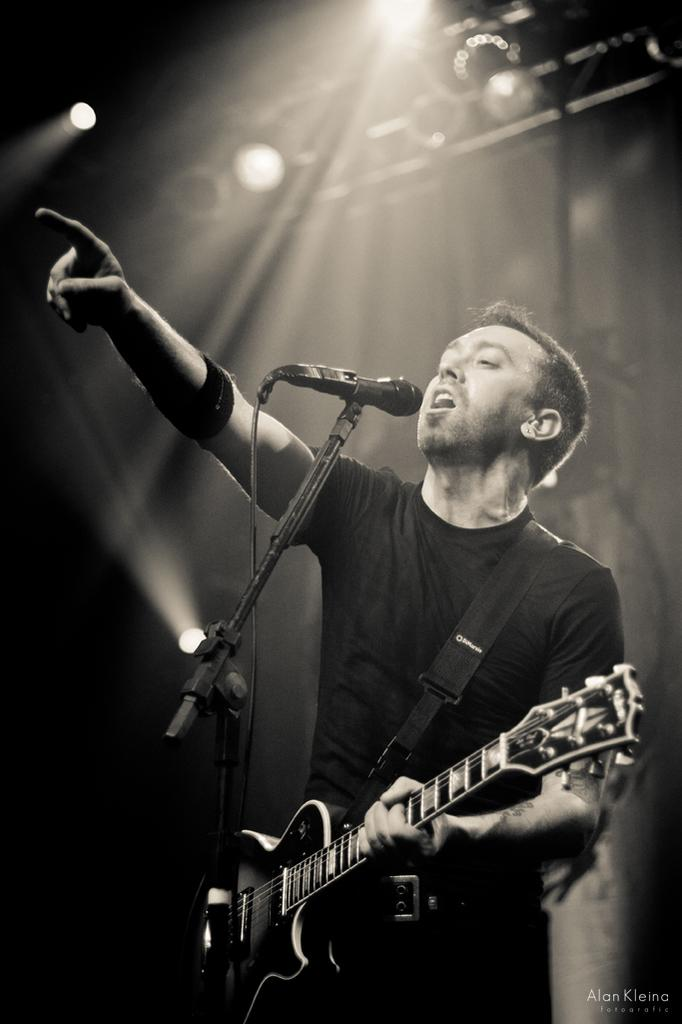What is the man in the image doing? The man is playing a guitar and singing. What object is the man using to amplify his voice? The man is in front of a microphone. What other object is present in the image? There is a stand in the image. What can be seen in the background of the image? There is a light in the background of the image. What type of cloud is visible in the image? There is no cloud visible in the image; it is focused on the man playing the guitar and singing. 